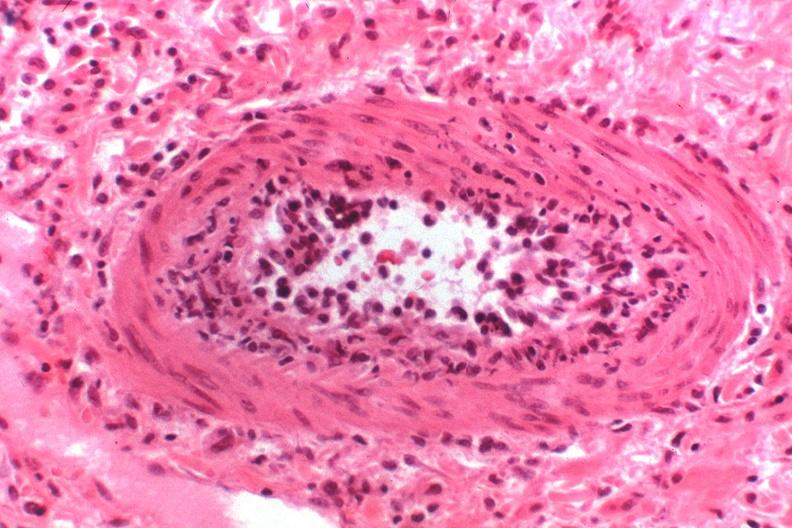what does this image show?
Answer the question using a single word or phrase. Kidney transplant rejection 